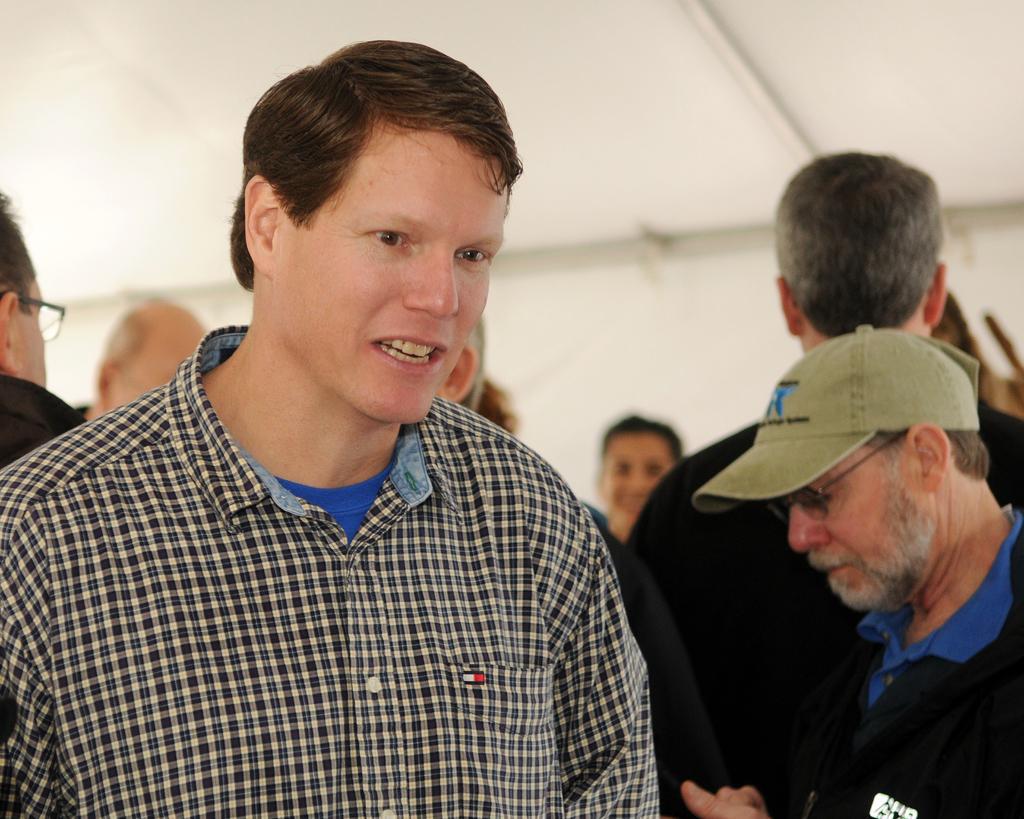Can you describe this image briefly? In this image, we can see a person talking. In the background, there is a blur view and people. On the right side of the image, we can see a person wearing a cap, glasses and holding an object. 